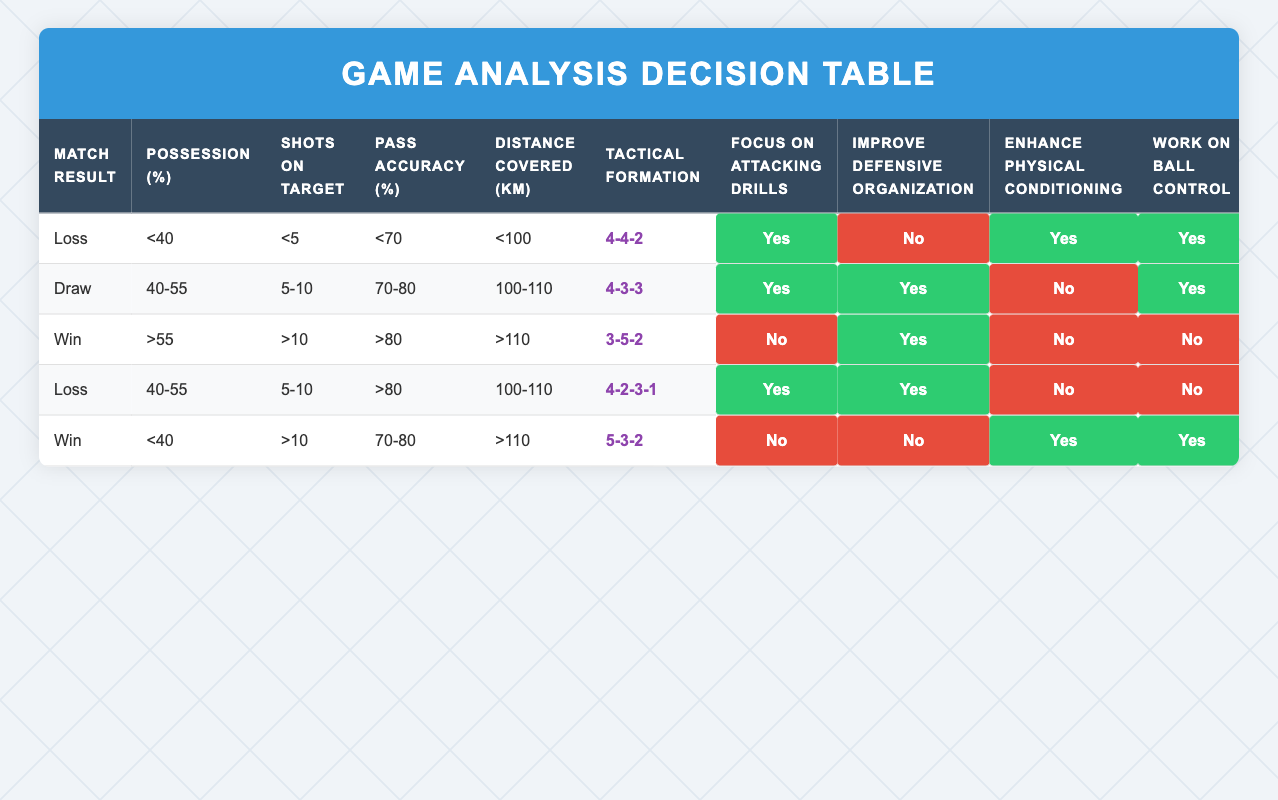What actions should be taken if the match result is a loss with possession less than 40%? According to the rules for a loss with possession less than 40%, the actions to take are to focus on attacking drills, enhance physical conditioning, work on ball control, adjust the tactical approach, and analyze the opposition strategy. There is no emphasis on improving defensive organization.
Answer: Focus on attacking drills, enhance physical conditioning, work on ball control, adjust tactical approach, analyze opposition strategy What is the tactical formation associated with a win having possession greater than 55%? The rule for a win with possession greater than 55% indicates that the tactical formation should be 3-5-2. This can be found by looking specifically at the row that shows a win and compares the possession percentage.
Answer: 3-5-2 Is there a match where possession between 40% and 55% and pass accuracy greater than 80% resulted in focusing on defensive organization? Yes, there is a match with the result being a loss, possessing between 40% to 55%, and having pass accuracy greater than 80% which suggests that the team should improve defensive organization, alongside other actions including focusing on attacking drills and analyzing opposition strategy.
Answer: Yes What percentage of matches resulted in a win where the shot count was greater than 10? There are two matches where the result was a win with greater than 10 shots on target. One match has possession less than 40% and the other has possession greater than 55%. Thus, 2 out of 5 records are wins under the condition of more than 10 shots on target, yielding a 40% occurrence of this pattern.
Answer: 40% If a team has drawn with 5 to 10 shots on target, what actions need to be improved? For a match result of a draw with 5 to 10 shots on target, the recommended actions involve focusing on attacking drills, improving defensive organization, and working on ball control. The team does not need to enhance physical conditioning or adjust the tactical approach, but should analyze the opposition strategy.
Answer: Focus on attacking drills, improve defensive organization, work on ball control 